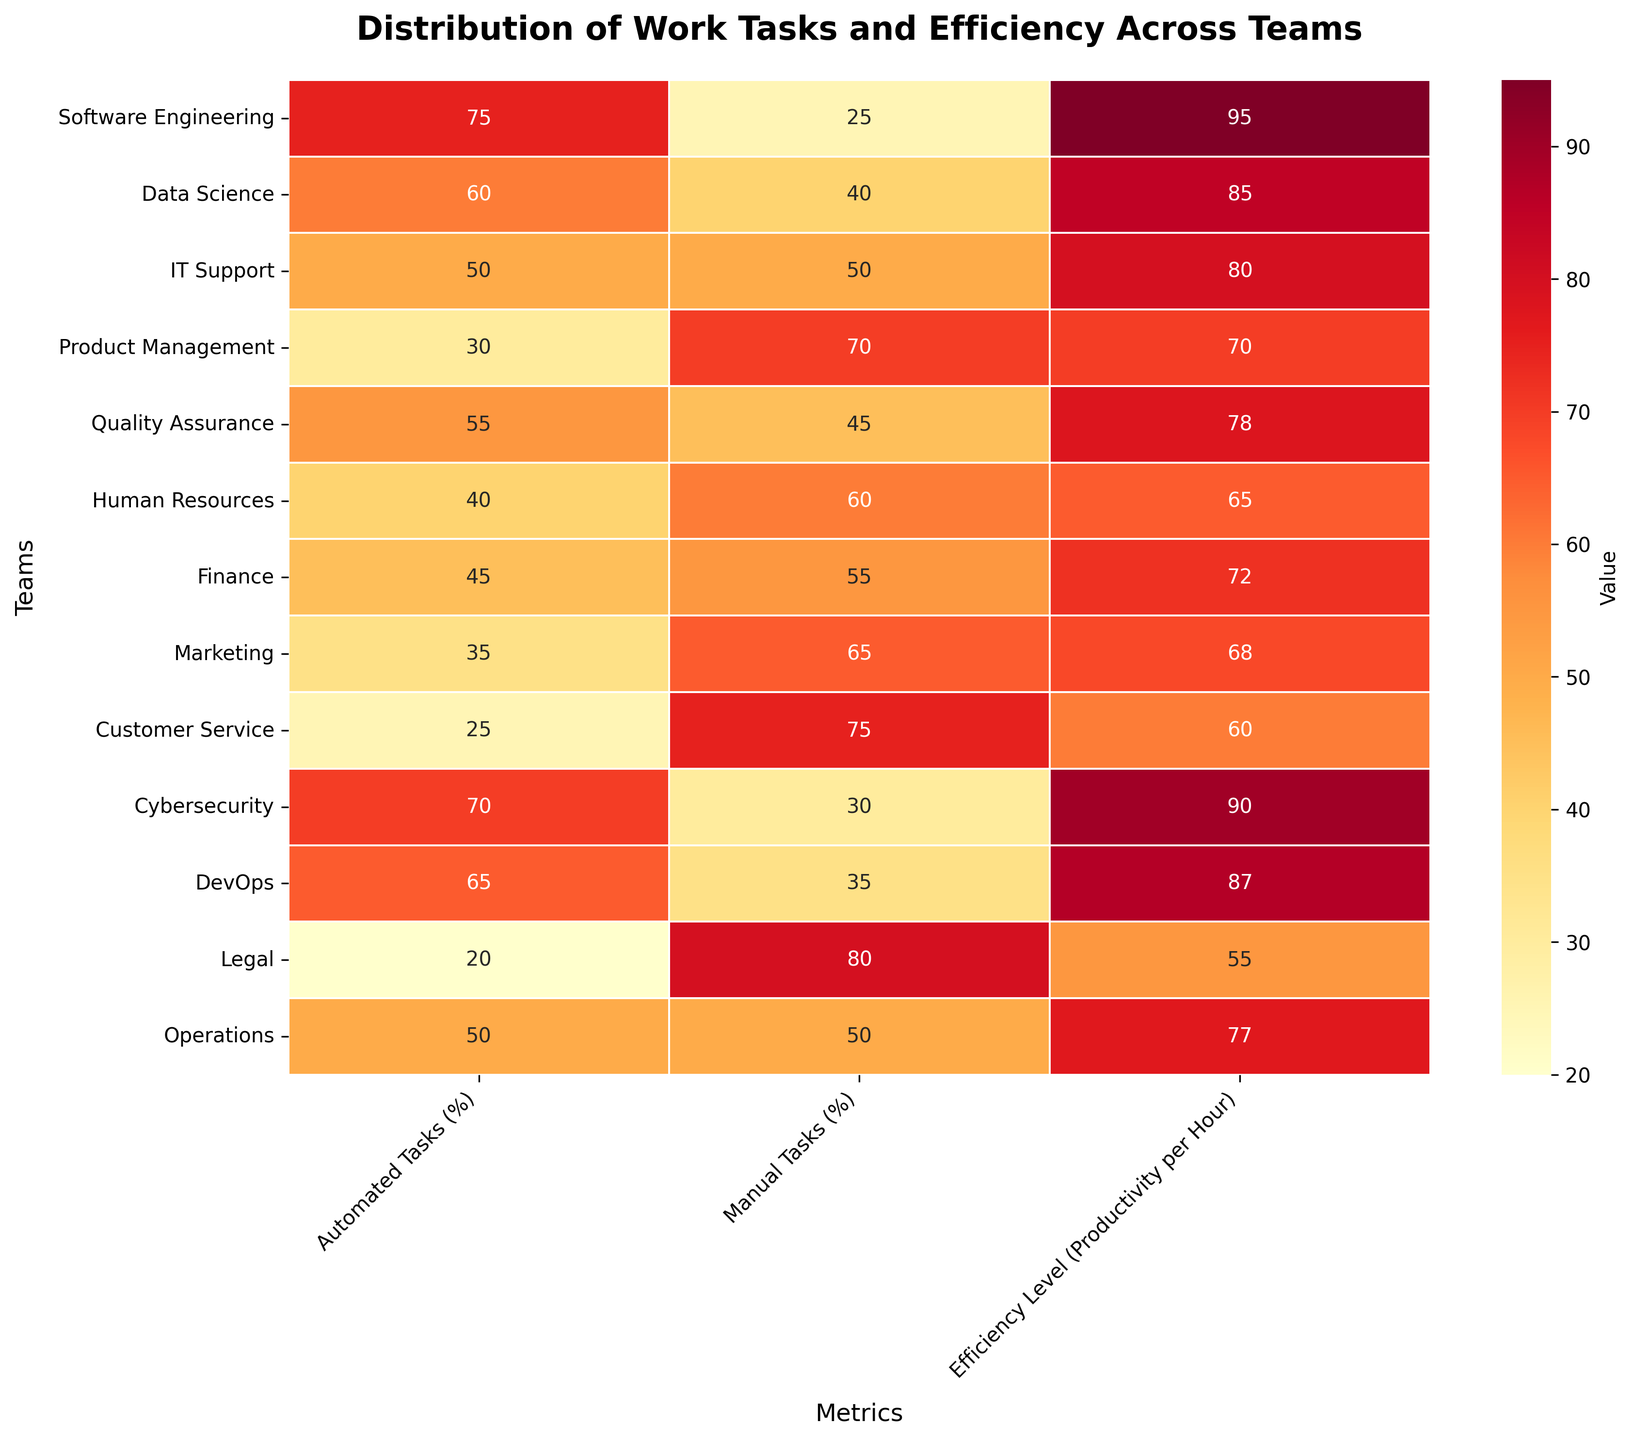what is the title of the heatmap? The title is displayed at the top of the heatmap in bold font. The visual immediately indicates that it describes task distribution and efficiency across teams.
Answer: Distribution of Work Tasks and Efficiency Across Teams Which team has the highest percentage of automated tasks? The heatmap shows the percentage values for automated tasks in the first column. The highest value can be found by comparing these values.
Answer: Software Engineering Which team has the lowest efficiency level? The heatmap presents the efficiency levels in the third column labeled 'Efficiency Level (Productivity per Hour)'. By comparing these values, the lowest can be identified.
Answer: Legal What is the difference in the percentage of automated tasks between the Software Engineering and Legal teams? The automated tasks percentage for Software Engineering and Legal are 75% and 20%, respectively. Subtract the smaller number from the larger one: 75 - 20 = 55.
Answer: 55 How many teams have an efficiency level above 80? Looking at the third column, identify and count all teams with an efficiency level greater than 80. The teams are Software Engineering, Data Science, Cybersecurity, and DevOps.
Answer: 4 Which team has the closest percentage of manual tasks to IT Support? IT Support has 50% in manual tasks. By comparing all teams' manual task percentages, Operations also has 50%.
Answer: Operations What are the automated tasks percentages of teams with efficiency levels below 70? Look at the third column to find teams with efficiency levels below 70: Human Resources, Marketing, Customer Service, Legal. Then, check their automated tasks percentages in the first column: HR: 40%, Marketing: 35%, Customer Service: 25%, Legal: 20%.
Answer: 40%, 35%, 25%, 20% Which teams have an equal percentage of automated and manual tasks? Teams with equal values in the first and second columns are identified as having an equal percentage of automated and manual tasks. IT Support and Operations both have 50%.
Answer: IT Support, Operations Is there a correlation between the percentage of automated tasks and efficiency levels across teams? By observing the heatmap, one can visually identify trends or patterns. Teams with higher automated task percentages generally have higher efficiency levels, suggesting a positive correlation.
Answer: Yes 